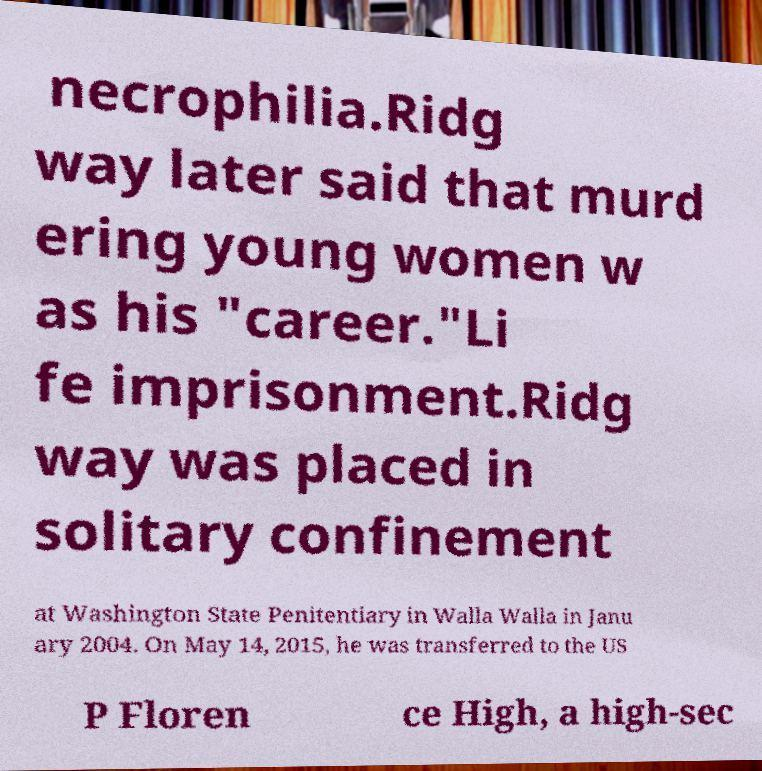I need the written content from this picture converted into text. Can you do that? necrophilia.Ridg way later said that murd ering young women w as his "career."Li fe imprisonment.Ridg way was placed in solitary confinement at Washington State Penitentiary in Walla Walla in Janu ary 2004. On May 14, 2015, he was transferred to the US P Floren ce High, a high-sec 